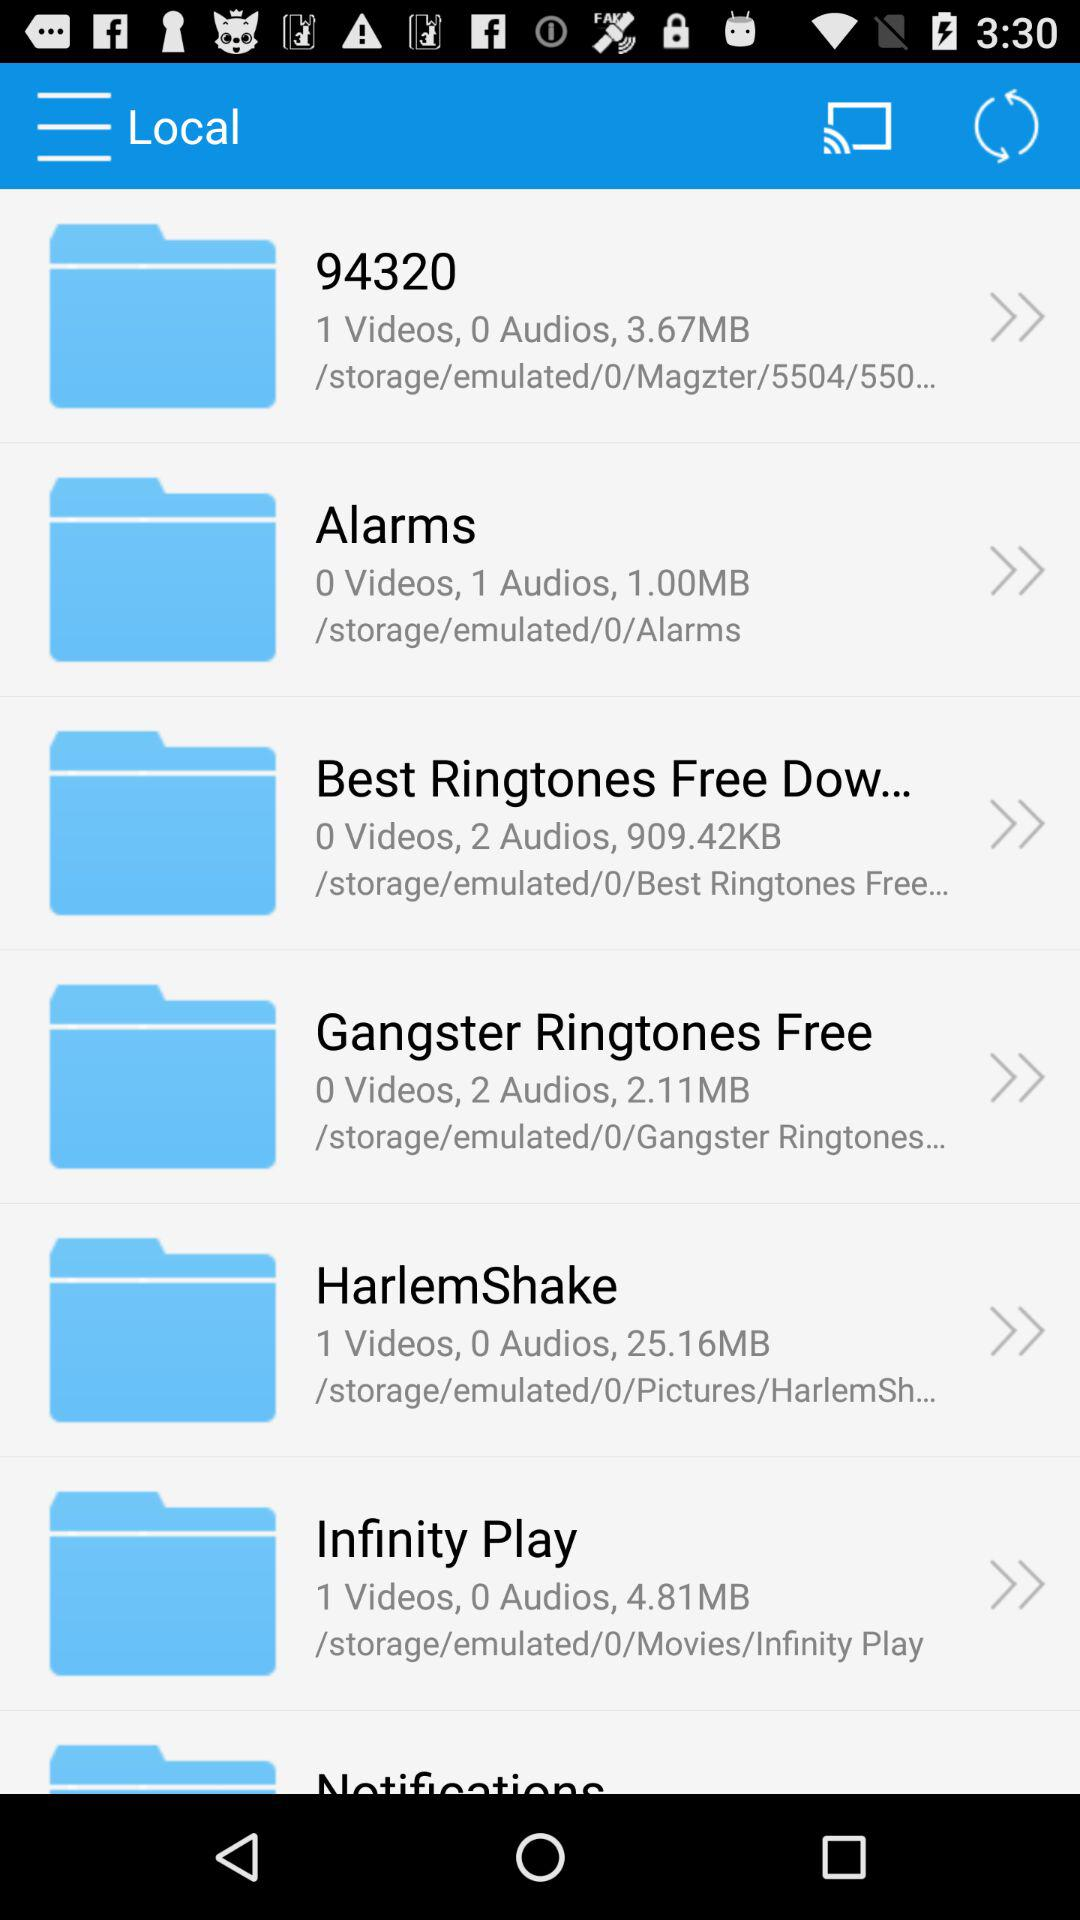In which folder is there 1 audio available? The folder is "Alarms". 